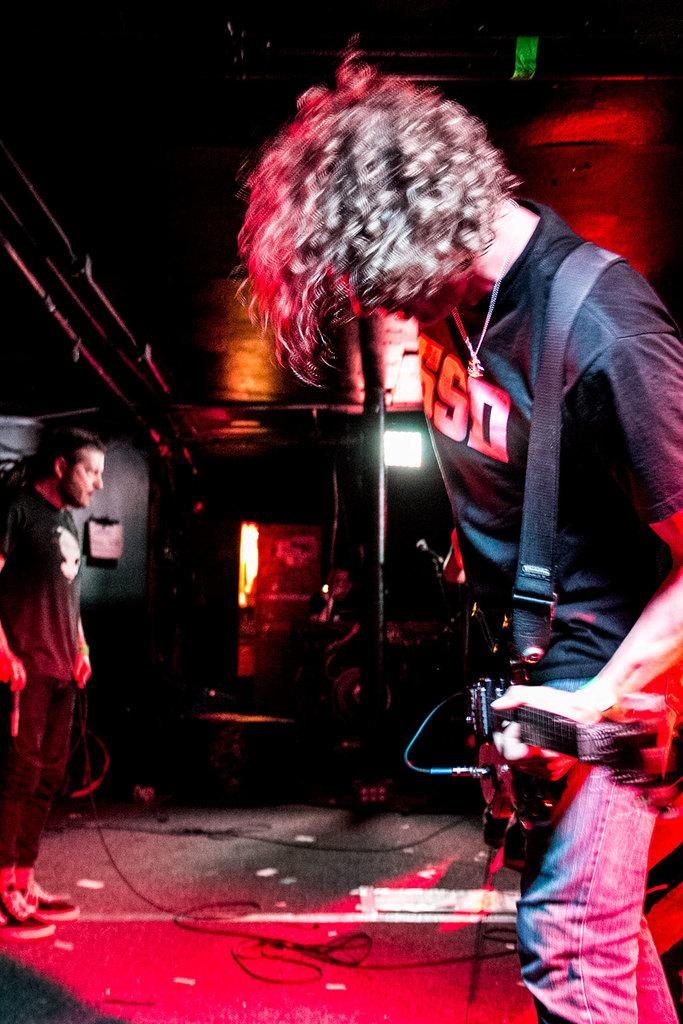What is the person on the right side of the image holding? The person on the right side is holding a guitar. What is the person on the left side of the image doing? The person on the left side is looking at someone. How many people are visible in the image? There are two people visible in the image. What type of knowledge is the person on the right side of the image sharing with the scene? There is no indication in the image that the person on the right side is sharing any knowledge with the scene. 